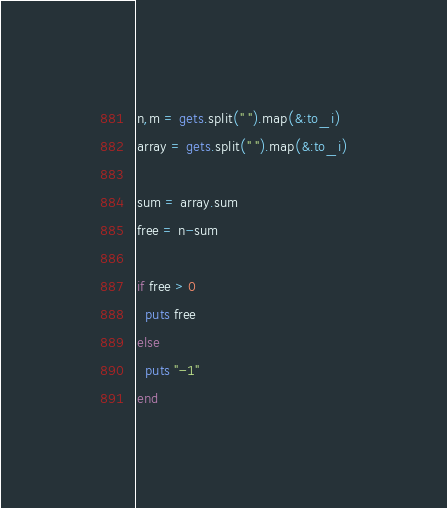<code> <loc_0><loc_0><loc_500><loc_500><_Ruby_>n,m = gets.split(" ").map(&:to_i)
array = gets.split(" ").map(&:to_i)

sum = array.sum
free = n-sum

if free > 0
  puts free
else
  puts "-1"
end</code> 